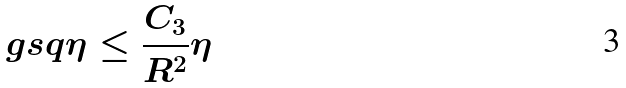<formula> <loc_0><loc_0><loc_500><loc_500>\ g s q { \eta } \leq \frac { C _ { 3 } } { R ^ { 2 } } \eta \\</formula> 